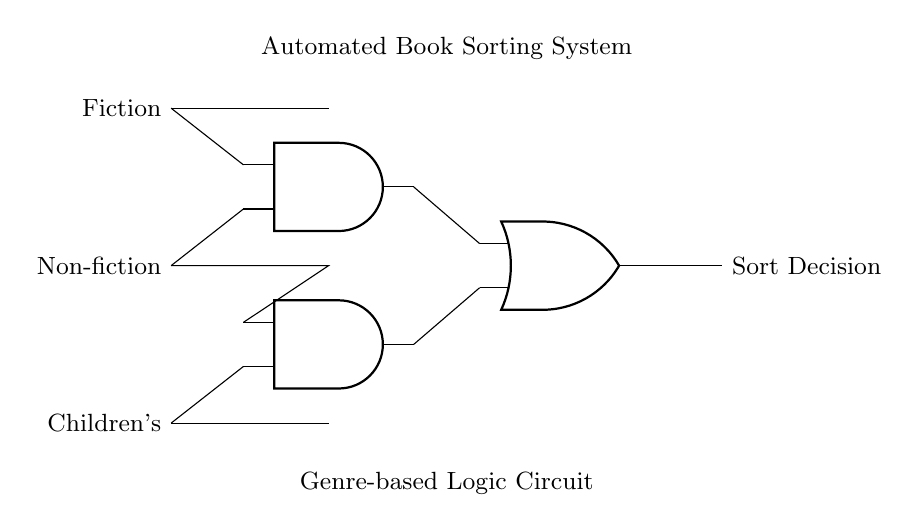What are the input lines labeled? The input lines are labeled as Fiction, Non-fiction, and Children's, which indicate the genres to be sorted.
Answer: Fiction, Non-fiction, Children's How many AND gates are present in the circuit? There are two AND gates in the circuit, as indicated by the two distinct symbols for AND gates located at coordinates (2, 4) and (2, 2).
Answer: Two What is the output of the OR gate? The output of the OR gate is labeled Sort Decision, representing the final sorting decision based on the inputs processed by the two AND gates.
Answer: Sort Decision Which genres are connected to the second AND gate? The second AND gate is connected to Non-fiction and Children's inputs, as indicated by the connections made at the corresponding coordinates.
Answer: Non-fiction, Children's How does the circuit categorize a book as Fiction? The circuit categorizes a book as Fiction when the Fiction input is active, triggering the first AND gate to produce an output that reaches the OR gate for sorting.
Answer: Active Fiction input What type of logic does this circuit utilize to process inputs? This circuit utilizes both AND and OR logic to process the inputs, where the AND gates determine specific conditions that must be true before sending a signal to the OR gate for the final decision.
Answer: AND and OR logic 